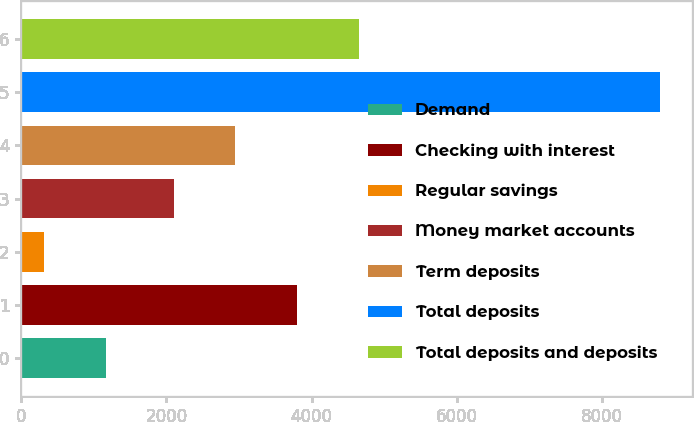<chart> <loc_0><loc_0><loc_500><loc_500><bar_chart><fcel>Demand<fcel>Checking with interest<fcel>Regular savings<fcel>Money market accounts<fcel>Term deposits<fcel>Total deposits<fcel>Total deposits and deposits<nl><fcel>1163.9<fcel>3797.8<fcel>315<fcel>2100<fcel>2948.9<fcel>8804<fcel>4646.7<nl></chart> 